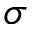<formula> <loc_0><loc_0><loc_500><loc_500>\sigma</formula> 